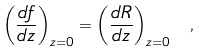Convert formula to latex. <formula><loc_0><loc_0><loc_500><loc_500>\left ( \frac { d f } { d z } \right ) _ { z = 0 } = \left ( \frac { d R } { d z } \right ) _ { z = 0 } \ ,</formula> 